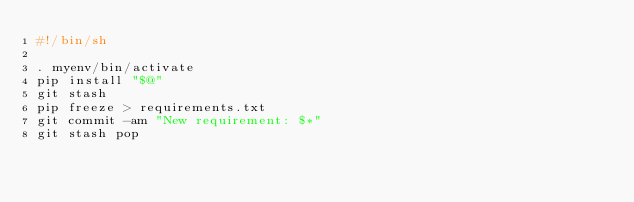Convert code to text. <code><loc_0><loc_0><loc_500><loc_500><_Bash_>#!/bin/sh

. myenv/bin/activate
pip install "$@"
git stash
pip freeze > requirements.txt
git commit -am "New requirement: $*"
git stash pop

</code> 